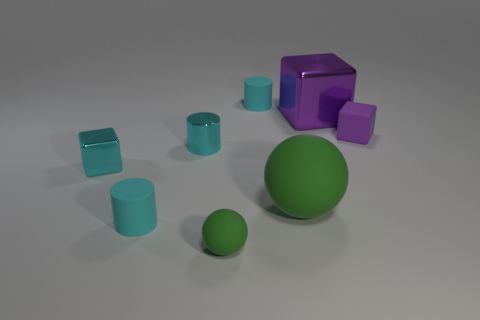How many cyan cylinders must be subtracted to get 1 cyan cylinders? 2 Subtract all yellow cylinders. Subtract all green balls. How many cylinders are left? 3 Add 1 large green metallic spheres. How many objects exist? 9 Subtract all cylinders. How many objects are left? 5 Subtract 0 blue balls. How many objects are left? 8 Subtract all gray matte cylinders. Subtract all large balls. How many objects are left? 7 Add 7 green balls. How many green balls are left? 9 Add 7 small cylinders. How many small cylinders exist? 10 